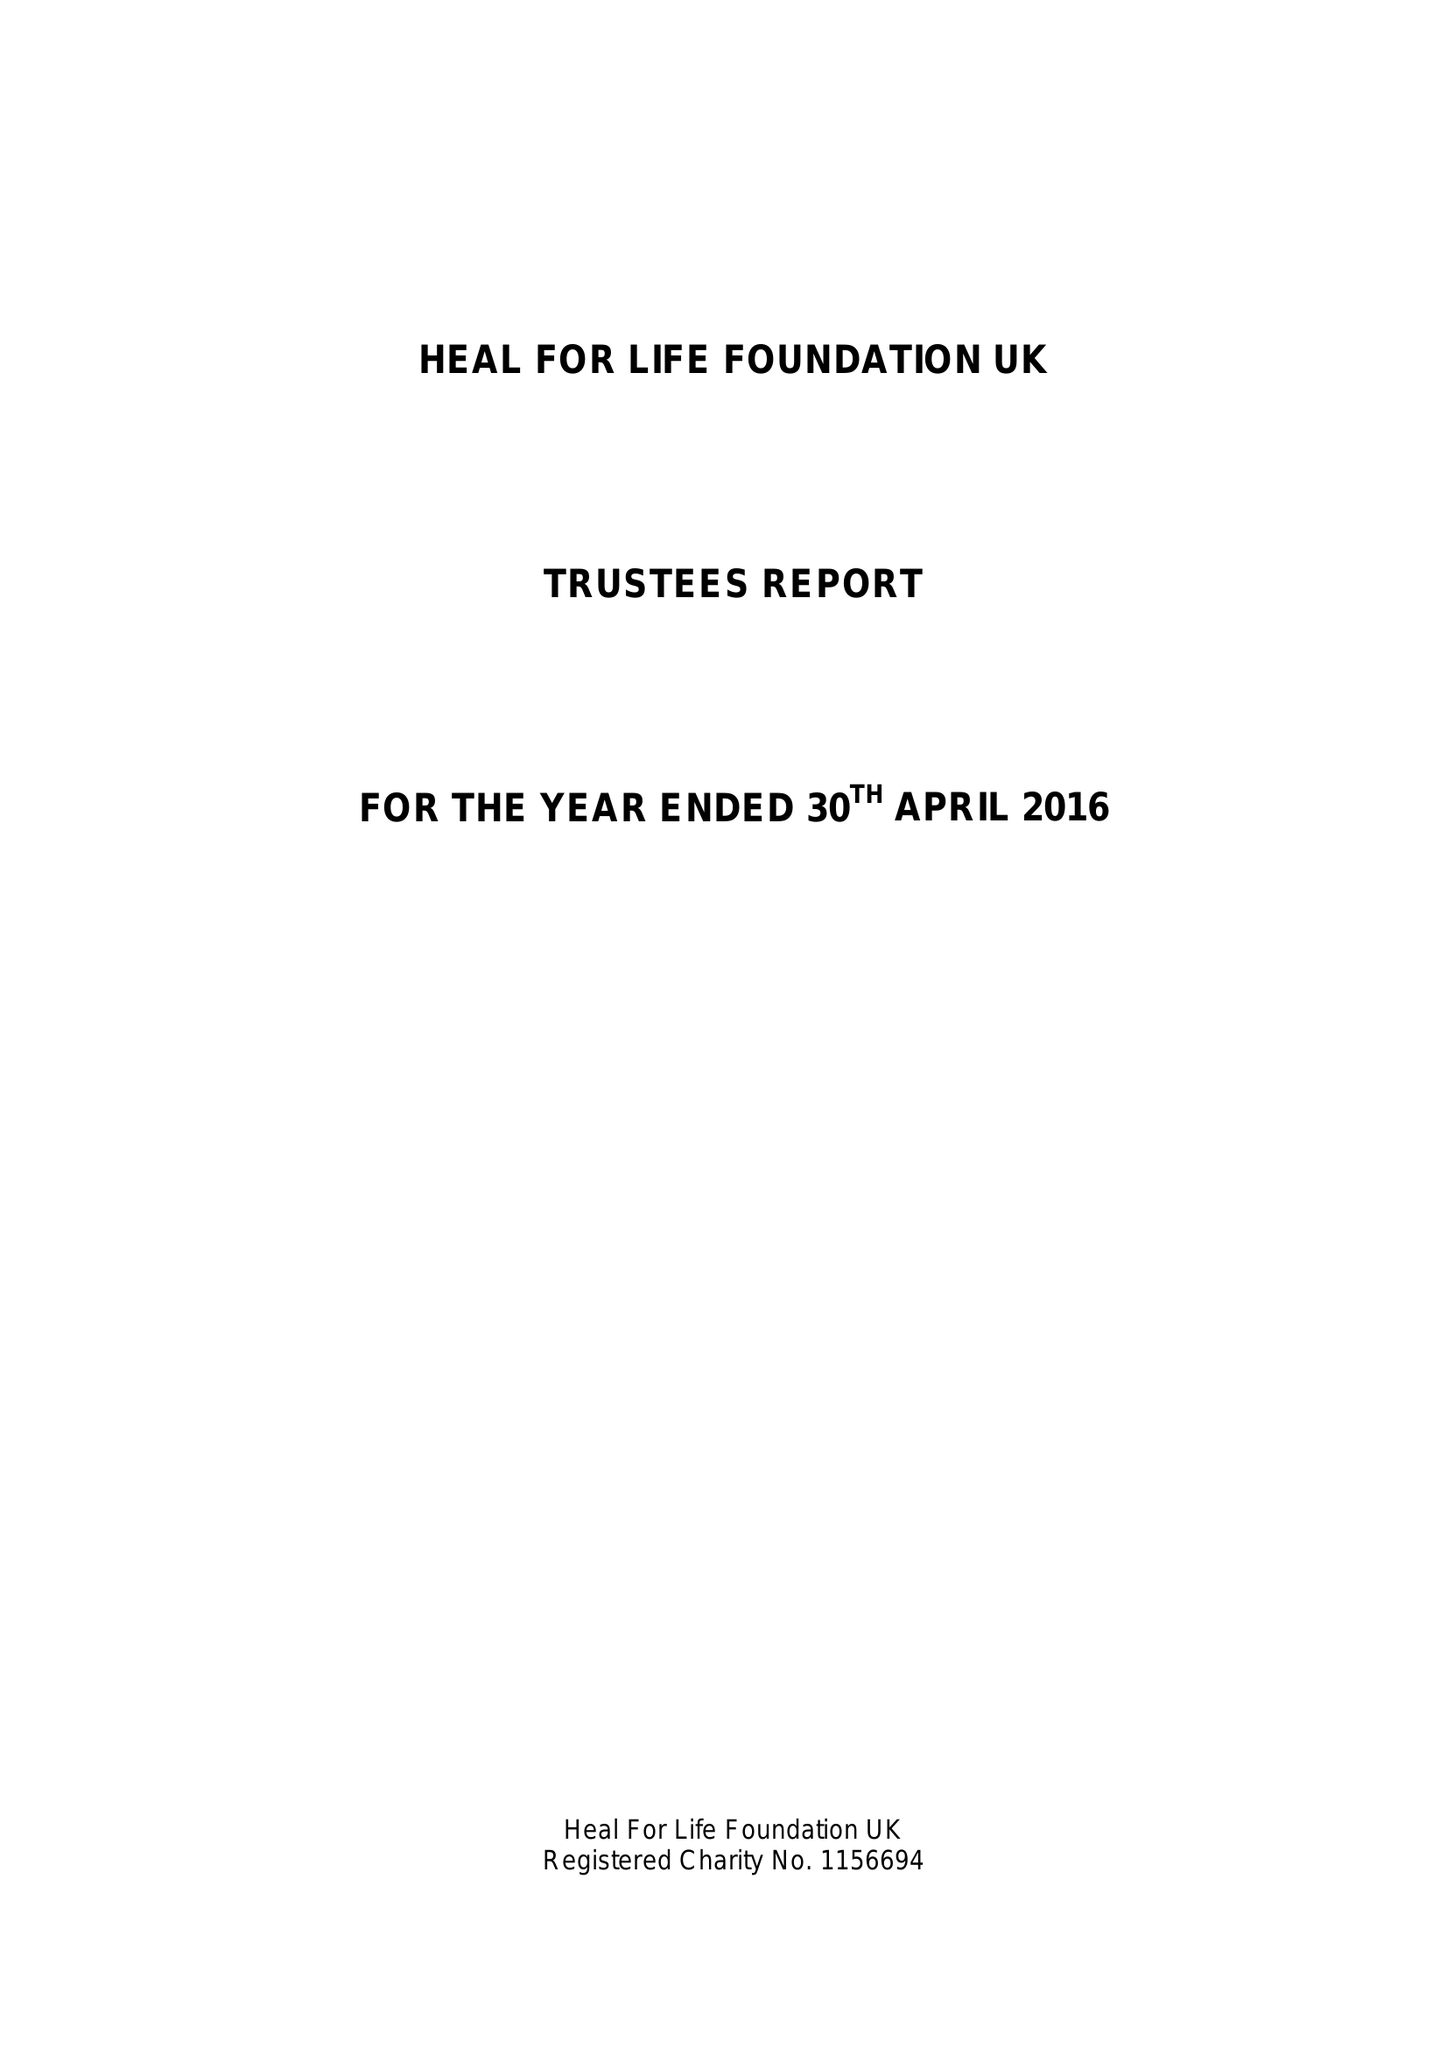What is the value for the spending_annually_in_british_pounds?
Answer the question using a single word or phrase. 11249.41 